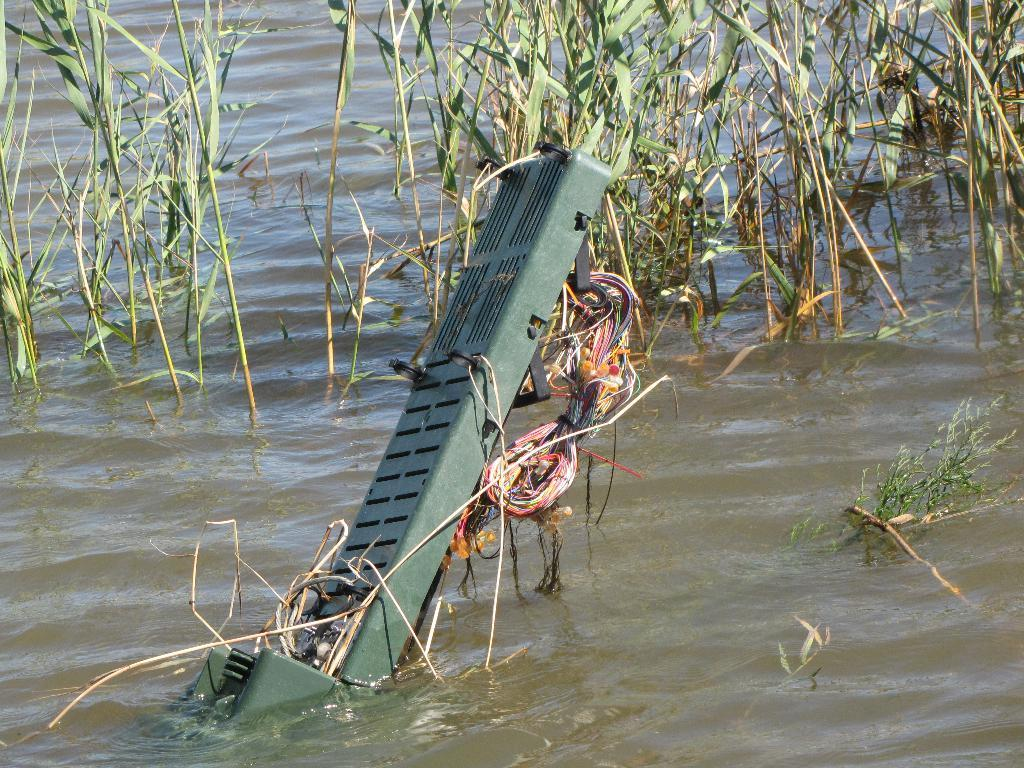What type of vegetation is present in the image? There is grass in the image. What else can be seen in the image besides the grass? There are wires and water visible in the image. What letters can be seen on the cup in the image? There is no cup present in the image, so no letters can be seen on a cup. 